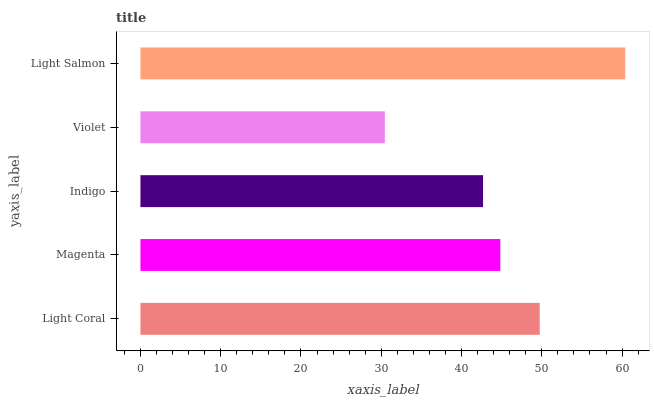Is Violet the minimum?
Answer yes or no. Yes. Is Light Salmon the maximum?
Answer yes or no. Yes. Is Magenta the minimum?
Answer yes or no. No. Is Magenta the maximum?
Answer yes or no. No. Is Light Coral greater than Magenta?
Answer yes or no. Yes. Is Magenta less than Light Coral?
Answer yes or no. Yes. Is Magenta greater than Light Coral?
Answer yes or no. No. Is Light Coral less than Magenta?
Answer yes or no. No. Is Magenta the high median?
Answer yes or no. Yes. Is Magenta the low median?
Answer yes or no. Yes. Is Violet the high median?
Answer yes or no. No. Is Light Coral the low median?
Answer yes or no. No. 